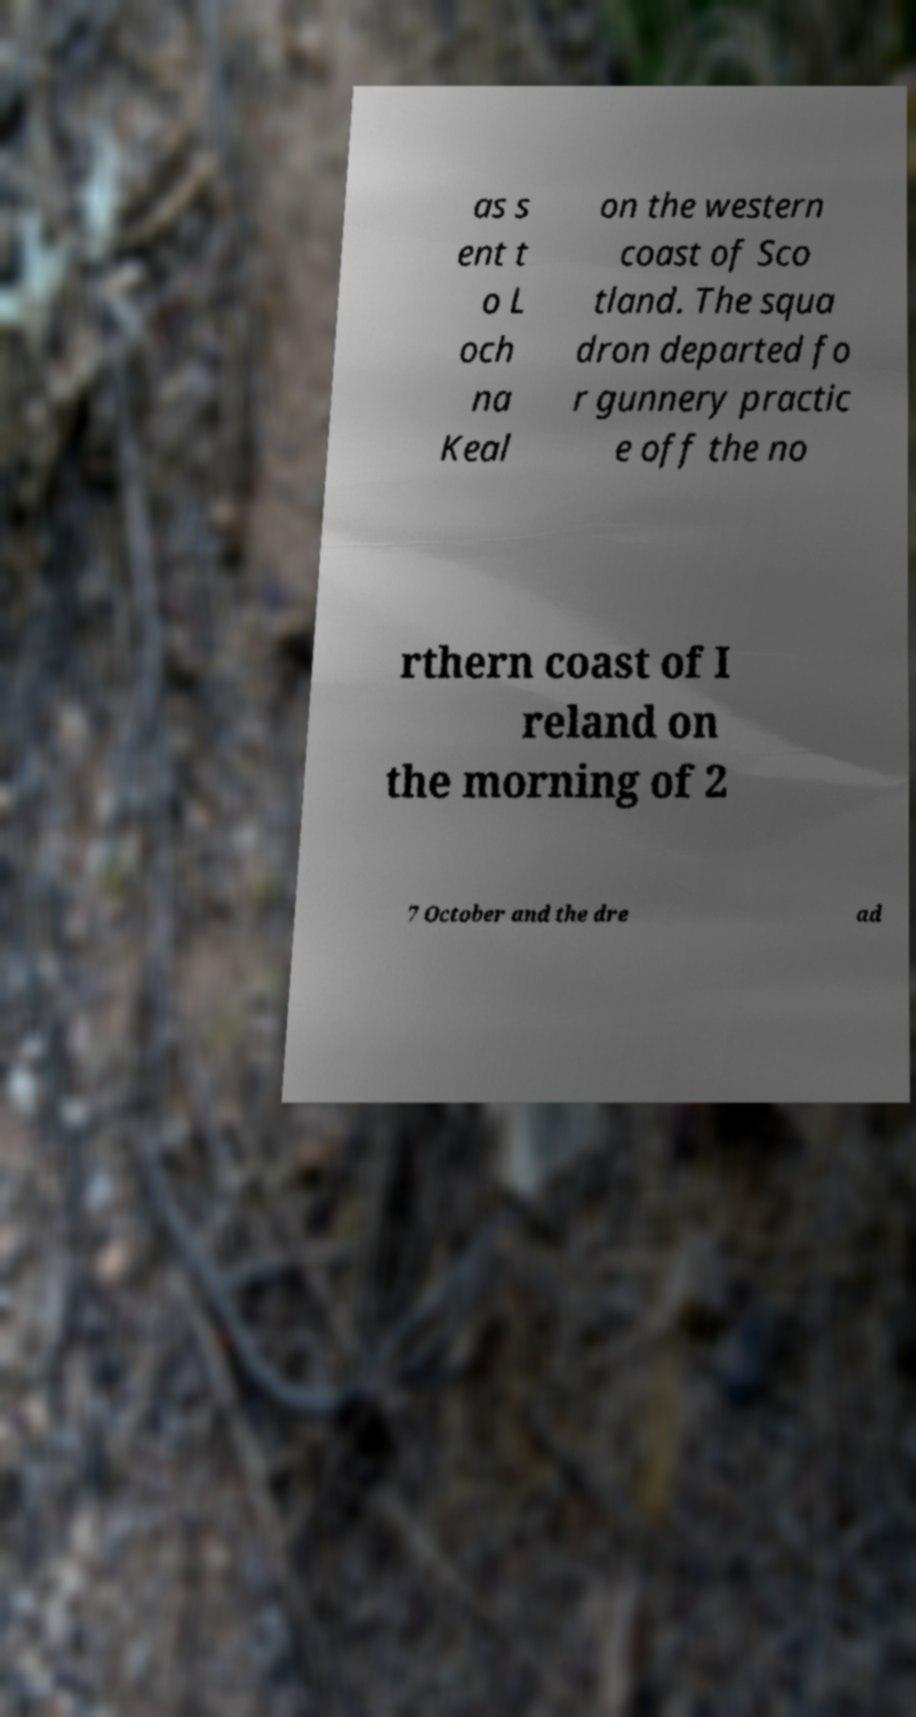Please read and relay the text visible in this image. What does it say? as s ent t o L och na Keal on the western coast of Sco tland. The squa dron departed fo r gunnery practic e off the no rthern coast of I reland on the morning of 2 7 October and the dre ad 